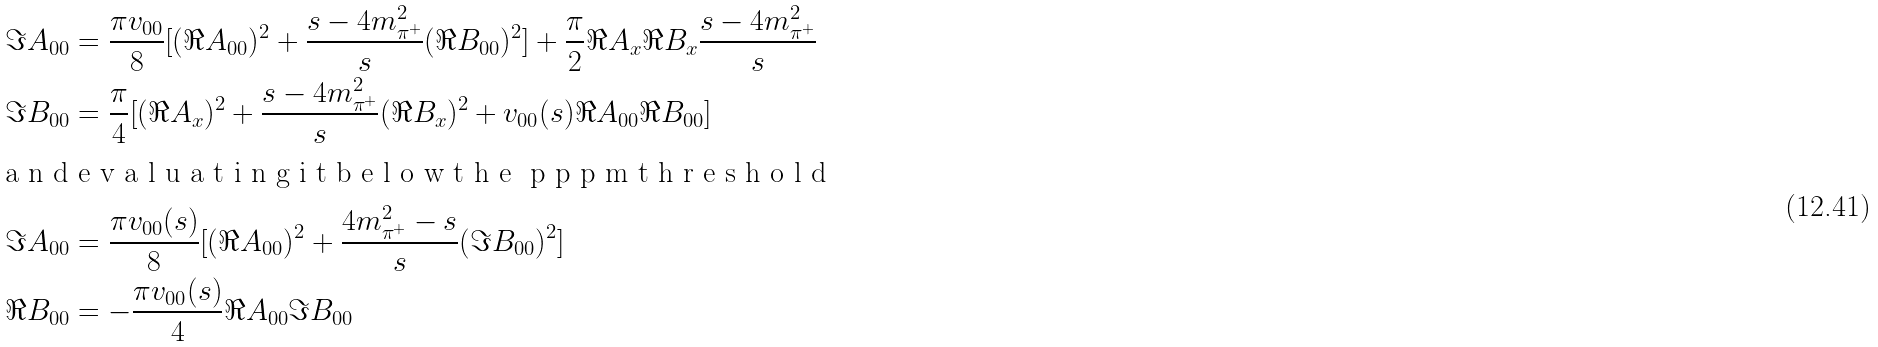<formula> <loc_0><loc_0><loc_500><loc_500>\Im A _ { 0 0 } & = \frac { \pi v _ { 0 0 } } { 8 } [ ( \Re A _ { 0 0 } ) ^ { 2 } + \frac { s - 4 m _ { \pi ^ { + } } ^ { 2 } } { s } ( \Re B _ { 0 0 } ) ^ { 2 } ] + \frac { \pi } { 2 } \Re A _ { x } \Re B _ { x } \frac { s - 4 m _ { \pi ^ { + } } ^ { 2 } } { s } \\ \Im B _ { 0 0 } & = \frac { \pi } { 4 } [ ( \Re A _ { x } ) ^ { 2 } + \frac { s - 4 m _ { \pi ^ { + } } ^ { 2 } } { s } ( \Re B _ { x } ) ^ { 2 } + v _ { 0 0 } ( s ) \Re A _ { 0 0 } \Re B _ { 0 0 } ] \intertext { a n d e v a l u a t i n g i t b e l o w t h e \ p p p m t h r e s h o l d } \Im A _ { 0 0 } & = \frac { \pi v _ { 0 0 } ( s ) } { 8 } [ ( \Re A _ { 0 0 } ) ^ { 2 } + \frac { 4 m _ { \pi ^ { + } } ^ { 2 } - s } { s } ( \Im B _ { 0 0 } ) ^ { 2 } ] \\ \Re B _ { 0 0 } & = - \frac { \pi v _ { 0 0 } ( s ) } { 4 } \Re A _ { 0 0 } \Im B _ { 0 0 }</formula> 